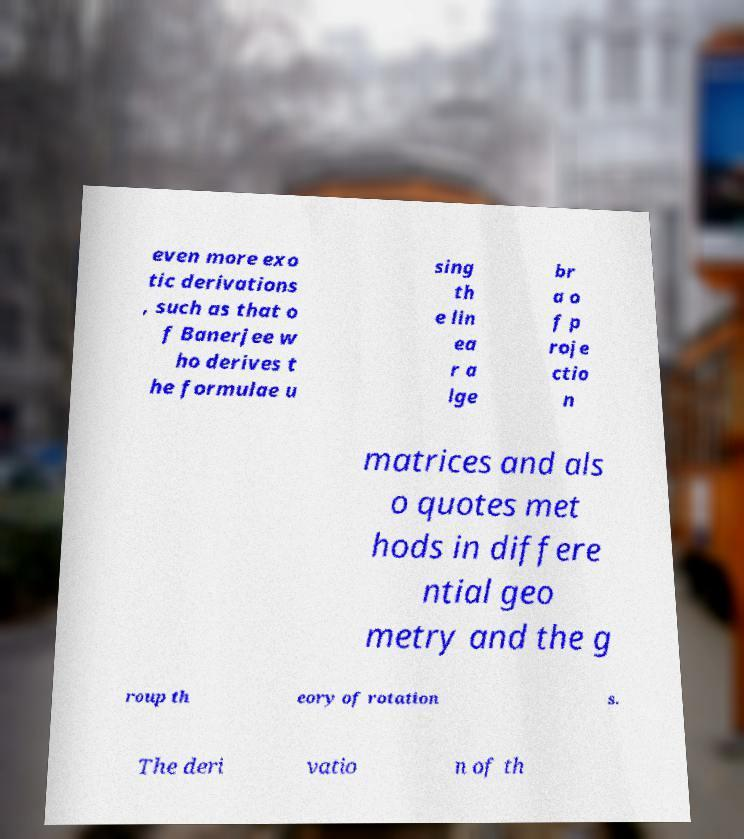For documentation purposes, I need the text within this image transcribed. Could you provide that? even more exo tic derivations , such as that o f Banerjee w ho derives t he formulae u sing th e lin ea r a lge br a o f p roje ctio n matrices and als o quotes met hods in differe ntial geo metry and the g roup th eory of rotation s. The deri vatio n of th 